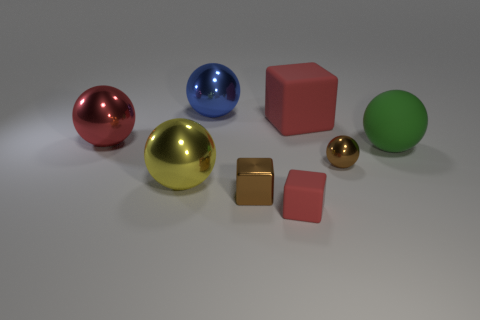What material is the brown ball that is the same size as the shiny cube?
Make the answer very short. Metal. How many tiny things are either blue shiny objects or spheres?
Your answer should be compact. 1. Does the large blue object have the same shape as the tiny rubber thing?
Give a very brief answer. No. How many large spheres are both in front of the red sphere and on the left side of the small brown ball?
Your answer should be compact. 1. Are there any other things that are the same color as the large matte cube?
Your answer should be very brief. Yes. The large blue thing that is the same material as the big red sphere is what shape?
Provide a succinct answer. Sphere. Do the blue metallic ball and the yellow ball have the same size?
Ensure brevity in your answer.  Yes. Do the small cube that is in front of the tiny metallic block and the large red ball have the same material?
Make the answer very short. No. Are there any other things that are made of the same material as the big blue ball?
Ensure brevity in your answer.  Yes. How many brown shiny objects are on the left side of the shiny ball that is on the right side of the red rubber thing that is in front of the big red shiny ball?
Provide a short and direct response. 1. 